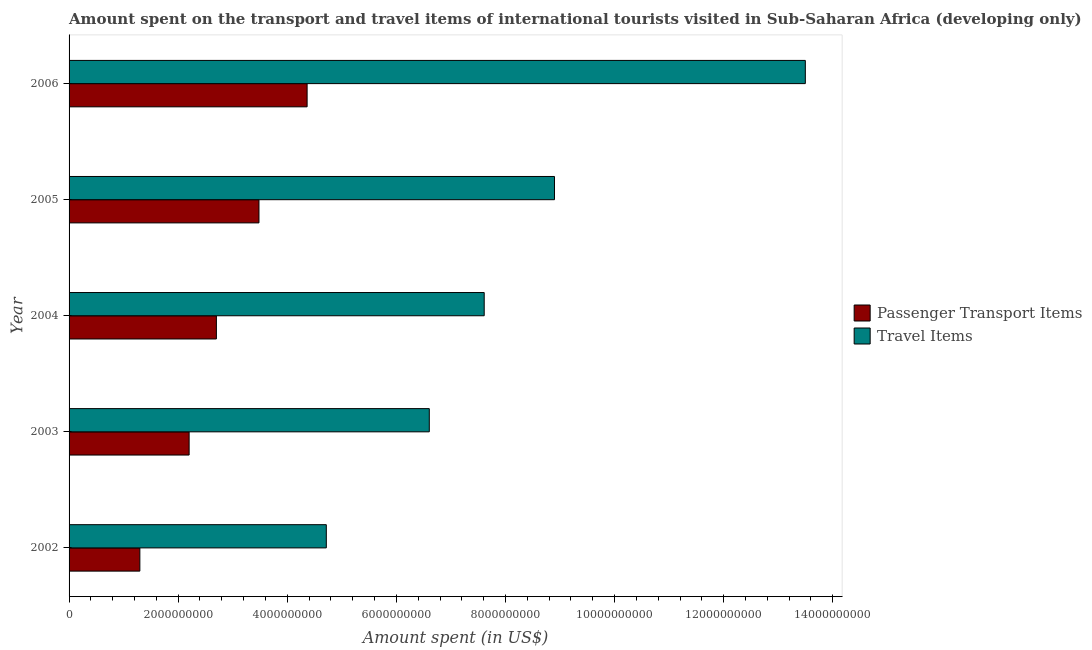How many different coloured bars are there?
Your answer should be very brief. 2. How many bars are there on the 5th tick from the top?
Offer a very short reply. 2. What is the label of the 1st group of bars from the top?
Keep it short and to the point. 2006. In how many cases, is the number of bars for a given year not equal to the number of legend labels?
Give a very brief answer. 0. What is the amount spent on passenger transport items in 2004?
Offer a terse response. 2.70e+09. Across all years, what is the maximum amount spent on passenger transport items?
Keep it short and to the point. 4.36e+09. Across all years, what is the minimum amount spent on passenger transport items?
Provide a short and direct response. 1.30e+09. What is the total amount spent on passenger transport items in the graph?
Your answer should be very brief. 1.40e+1. What is the difference between the amount spent in travel items in 2003 and that in 2006?
Provide a short and direct response. -6.89e+09. What is the difference between the amount spent in travel items in 2003 and the amount spent on passenger transport items in 2006?
Provide a short and direct response. 2.24e+09. What is the average amount spent in travel items per year?
Your response must be concise. 8.27e+09. In the year 2004, what is the difference between the amount spent in travel items and amount spent on passenger transport items?
Ensure brevity in your answer.  4.91e+09. In how many years, is the amount spent on passenger transport items greater than 2400000000 US$?
Make the answer very short. 3. What is the ratio of the amount spent in travel items in 2004 to that in 2006?
Ensure brevity in your answer.  0.56. Is the difference between the amount spent on passenger transport items in 2002 and 2003 greater than the difference between the amount spent in travel items in 2002 and 2003?
Your answer should be very brief. Yes. What is the difference between the highest and the second highest amount spent in travel items?
Provide a succinct answer. 4.60e+09. What is the difference between the highest and the lowest amount spent in travel items?
Make the answer very short. 8.78e+09. In how many years, is the amount spent on passenger transport items greater than the average amount spent on passenger transport items taken over all years?
Provide a succinct answer. 2. What does the 1st bar from the top in 2002 represents?
Give a very brief answer. Travel Items. What does the 1st bar from the bottom in 2003 represents?
Give a very brief answer. Passenger Transport Items. Are all the bars in the graph horizontal?
Ensure brevity in your answer.  Yes. What is the difference between two consecutive major ticks on the X-axis?
Provide a short and direct response. 2.00e+09. Does the graph contain any zero values?
Make the answer very short. No. Does the graph contain grids?
Make the answer very short. No. Where does the legend appear in the graph?
Your answer should be compact. Center right. How many legend labels are there?
Your answer should be compact. 2. What is the title of the graph?
Your answer should be very brief. Amount spent on the transport and travel items of international tourists visited in Sub-Saharan Africa (developing only). What is the label or title of the X-axis?
Provide a short and direct response. Amount spent (in US$). What is the label or title of the Y-axis?
Offer a very short reply. Year. What is the Amount spent (in US$) in Passenger Transport Items in 2002?
Your response must be concise. 1.30e+09. What is the Amount spent (in US$) in Travel Items in 2002?
Offer a terse response. 4.72e+09. What is the Amount spent (in US$) in Passenger Transport Items in 2003?
Keep it short and to the point. 2.20e+09. What is the Amount spent (in US$) in Travel Items in 2003?
Provide a short and direct response. 6.60e+09. What is the Amount spent (in US$) of Passenger Transport Items in 2004?
Your answer should be very brief. 2.70e+09. What is the Amount spent (in US$) in Travel Items in 2004?
Provide a succinct answer. 7.61e+09. What is the Amount spent (in US$) of Passenger Transport Items in 2005?
Your answer should be very brief. 3.48e+09. What is the Amount spent (in US$) of Travel Items in 2005?
Your response must be concise. 8.90e+09. What is the Amount spent (in US$) in Passenger Transport Items in 2006?
Give a very brief answer. 4.36e+09. What is the Amount spent (in US$) in Travel Items in 2006?
Provide a short and direct response. 1.35e+1. Across all years, what is the maximum Amount spent (in US$) of Passenger Transport Items?
Your answer should be compact. 4.36e+09. Across all years, what is the maximum Amount spent (in US$) in Travel Items?
Keep it short and to the point. 1.35e+1. Across all years, what is the minimum Amount spent (in US$) in Passenger Transport Items?
Make the answer very short. 1.30e+09. Across all years, what is the minimum Amount spent (in US$) of Travel Items?
Your answer should be very brief. 4.72e+09. What is the total Amount spent (in US$) in Passenger Transport Items in the graph?
Offer a terse response. 1.40e+1. What is the total Amount spent (in US$) in Travel Items in the graph?
Keep it short and to the point. 4.13e+1. What is the difference between the Amount spent (in US$) in Passenger Transport Items in 2002 and that in 2003?
Give a very brief answer. -9.03e+08. What is the difference between the Amount spent (in US$) of Travel Items in 2002 and that in 2003?
Keep it short and to the point. -1.89e+09. What is the difference between the Amount spent (in US$) of Passenger Transport Items in 2002 and that in 2004?
Ensure brevity in your answer.  -1.40e+09. What is the difference between the Amount spent (in US$) of Travel Items in 2002 and that in 2004?
Make the answer very short. -2.89e+09. What is the difference between the Amount spent (in US$) in Passenger Transport Items in 2002 and that in 2005?
Make the answer very short. -2.18e+09. What is the difference between the Amount spent (in US$) of Travel Items in 2002 and that in 2005?
Provide a succinct answer. -4.18e+09. What is the difference between the Amount spent (in US$) in Passenger Transport Items in 2002 and that in 2006?
Provide a succinct answer. -3.07e+09. What is the difference between the Amount spent (in US$) in Travel Items in 2002 and that in 2006?
Make the answer very short. -8.78e+09. What is the difference between the Amount spent (in US$) of Passenger Transport Items in 2003 and that in 2004?
Your response must be concise. -5.00e+08. What is the difference between the Amount spent (in US$) of Travel Items in 2003 and that in 2004?
Your response must be concise. -1.01e+09. What is the difference between the Amount spent (in US$) in Passenger Transport Items in 2003 and that in 2005?
Keep it short and to the point. -1.28e+09. What is the difference between the Amount spent (in US$) in Travel Items in 2003 and that in 2005?
Your answer should be very brief. -2.30e+09. What is the difference between the Amount spent (in US$) of Passenger Transport Items in 2003 and that in 2006?
Keep it short and to the point. -2.16e+09. What is the difference between the Amount spent (in US$) in Travel Items in 2003 and that in 2006?
Offer a terse response. -6.89e+09. What is the difference between the Amount spent (in US$) of Passenger Transport Items in 2004 and that in 2005?
Offer a terse response. -7.81e+08. What is the difference between the Amount spent (in US$) of Travel Items in 2004 and that in 2005?
Your answer should be very brief. -1.29e+09. What is the difference between the Amount spent (in US$) in Passenger Transport Items in 2004 and that in 2006?
Provide a short and direct response. -1.66e+09. What is the difference between the Amount spent (in US$) in Travel Items in 2004 and that in 2006?
Provide a succinct answer. -5.89e+09. What is the difference between the Amount spent (in US$) in Passenger Transport Items in 2005 and that in 2006?
Your answer should be very brief. -8.83e+08. What is the difference between the Amount spent (in US$) in Travel Items in 2005 and that in 2006?
Your answer should be very brief. -4.60e+09. What is the difference between the Amount spent (in US$) in Passenger Transport Items in 2002 and the Amount spent (in US$) in Travel Items in 2003?
Offer a terse response. -5.31e+09. What is the difference between the Amount spent (in US$) of Passenger Transport Items in 2002 and the Amount spent (in US$) of Travel Items in 2004?
Your answer should be very brief. -6.31e+09. What is the difference between the Amount spent (in US$) in Passenger Transport Items in 2002 and the Amount spent (in US$) in Travel Items in 2005?
Give a very brief answer. -7.60e+09. What is the difference between the Amount spent (in US$) of Passenger Transport Items in 2002 and the Amount spent (in US$) of Travel Items in 2006?
Offer a very short reply. -1.22e+1. What is the difference between the Amount spent (in US$) of Passenger Transport Items in 2003 and the Amount spent (in US$) of Travel Items in 2004?
Give a very brief answer. -5.41e+09. What is the difference between the Amount spent (in US$) of Passenger Transport Items in 2003 and the Amount spent (in US$) of Travel Items in 2005?
Ensure brevity in your answer.  -6.70e+09. What is the difference between the Amount spent (in US$) in Passenger Transport Items in 2003 and the Amount spent (in US$) in Travel Items in 2006?
Your response must be concise. -1.13e+1. What is the difference between the Amount spent (in US$) of Passenger Transport Items in 2004 and the Amount spent (in US$) of Travel Items in 2005?
Ensure brevity in your answer.  -6.20e+09. What is the difference between the Amount spent (in US$) of Passenger Transport Items in 2004 and the Amount spent (in US$) of Travel Items in 2006?
Give a very brief answer. -1.08e+1. What is the difference between the Amount spent (in US$) of Passenger Transport Items in 2005 and the Amount spent (in US$) of Travel Items in 2006?
Offer a terse response. -1.00e+1. What is the average Amount spent (in US$) in Passenger Transport Items per year?
Provide a short and direct response. 2.81e+09. What is the average Amount spent (in US$) of Travel Items per year?
Your response must be concise. 8.27e+09. In the year 2002, what is the difference between the Amount spent (in US$) in Passenger Transport Items and Amount spent (in US$) in Travel Items?
Your answer should be compact. -3.42e+09. In the year 2003, what is the difference between the Amount spent (in US$) of Passenger Transport Items and Amount spent (in US$) of Travel Items?
Provide a short and direct response. -4.40e+09. In the year 2004, what is the difference between the Amount spent (in US$) of Passenger Transport Items and Amount spent (in US$) of Travel Items?
Offer a very short reply. -4.91e+09. In the year 2005, what is the difference between the Amount spent (in US$) in Passenger Transport Items and Amount spent (in US$) in Travel Items?
Provide a succinct answer. -5.42e+09. In the year 2006, what is the difference between the Amount spent (in US$) in Passenger Transport Items and Amount spent (in US$) in Travel Items?
Your answer should be very brief. -9.13e+09. What is the ratio of the Amount spent (in US$) of Passenger Transport Items in 2002 to that in 2003?
Your response must be concise. 0.59. What is the ratio of the Amount spent (in US$) in Travel Items in 2002 to that in 2003?
Offer a terse response. 0.71. What is the ratio of the Amount spent (in US$) of Passenger Transport Items in 2002 to that in 2004?
Offer a very short reply. 0.48. What is the ratio of the Amount spent (in US$) of Travel Items in 2002 to that in 2004?
Your answer should be very brief. 0.62. What is the ratio of the Amount spent (in US$) of Passenger Transport Items in 2002 to that in 2005?
Offer a terse response. 0.37. What is the ratio of the Amount spent (in US$) in Travel Items in 2002 to that in 2005?
Make the answer very short. 0.53. What is the ratio of the Amount spent (in US$) of Passenger Transport Items in 2002 to that in 2006?
Make the answer very short. 0.3. What is the ratio of the Amount spent (in US$) of Travel Items in 2002 to that in 2006?
Your answer should be compact. 0.35. What is the ratio of the Amount spent (in US$) of Passenger Transport Items in 2003 to that in 2004?
Give a very brief answer. 0.81. What is the ratio of the Amount spent (in US$) in Travel Items in 2003 to that in 2004?
Make the answer very short. 0.87. What is the ratio of the Amount spent (in US$) in Passenger Transport Items in 2003 to that in 2005?
Provide a succinct answer. 0.63. What is the ratio of the Amount spent (in US$) in Travel Items in 2003 to that in 2005?
Keep it short and to the point. 0.74. What is the ratio of the Amount spent (in US$) in Passenger Transport Items in 2003 to that in 2006?
Your answer should be compact. 0.5. What is the ratio of the Amount spent (in US$) of Travel Items in 2003 to that in 2006?
Offer a very short reply. 0.49. What is the ratio of the Amount spent (in US$) of Passenger Transport Items in 2004 to that in 2005?
Offer a very short reply. 0.78. What is the ratio of the Amount spent (in US$) in Travel Items in 2004 to that in 2005?
Offer a very short reply. 0.86. What is the ratio of the Amount spent (in US$) of Passenger Transport Items in 2004 to that in 2006?
Your answer should be very brief. 0.62. What is the ratio of the Amount spent (in US$) of Travel Items in 2004 to that in 2006?
Keep it short and to the point. 0.56. What is the ratio of the Amount spent (in US$) in Passenger Transport Items in 2005 to that in 2006?
Keep it short and to the point. 0.8. What is the ratio of the Amount spent (in US$) of Travel Items in 2005 to that in 2006?
Make the answer very short. 0.66. What is the difference between the highest and the second highest Amount spent (in US$) of Passenger Transport Items?
Ensure brevity in your answer.  8.83e+08. What is the difference between the highest and the second highest Amount spent (in US$) of Travel Items?
Provide a succinct answer. 4.60e+09. What is the difference between the highest and the lowest Amount spent (in US$) in Passenger Transport Items?
Your answer should be very brief. 3.07e+09. What is the difference between the highest and the lowest Amount spent (in US$) in Travel Items?
Offer a very short reply. 8.78e+09. 